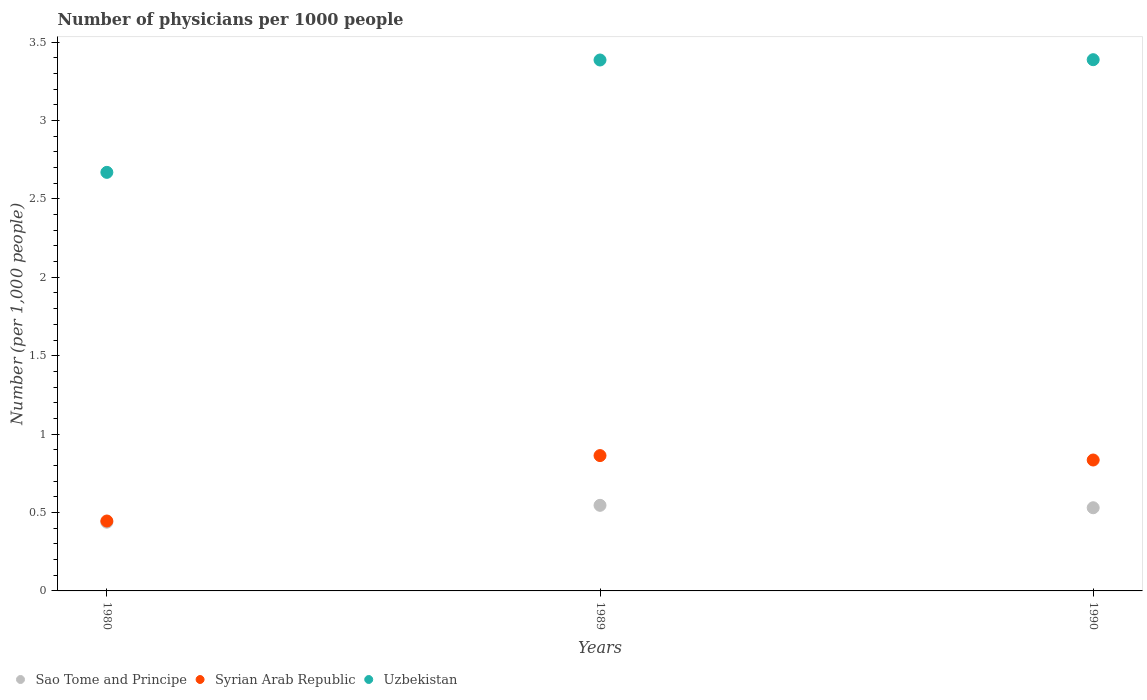Is the number of dotlines equal to the number of legend labels?
Your response must be concise. Yes. What is the number of physicians in Sao Tome and Principe in 1980?
Ensure brevity in your answer.  0.44. Across all years, what is the maximum number of physicians in Syrian Arab Republic?
Your answer should be compact. 0.86. Across all years, what is the minimum number of physicians in Syrian Arab Republic?
Ensure brevity in your answer.  0.45. In which year was the number of physicians in Sao Tome and Principe maximum?
Offer a terse response. 1989. In which year was the number of physicians in Uzbekistan minimum?
Keep it short and to the point. 1980. What is the total number of physicians in Sao Tome and Principe in the graph?
Your answer should be very brief. 1.51. What is the difference between the number of physicians in Uzbekistan in 1989 and that in 1990?
Provide a short and direct response. -0. What is the difference between the number of physicians in Syrian Arab Republic in 1980 and the number of physicians in Sao Tome and Principe in 1990?
Give a very brief answer. -0.08. What is the average number of physicians in Sao Tome and Principe per year?
Ensure brevity in your answer.  0.5. In the year 1989, what is the difference between the number of physicians in Sao Tome and Principe and number of physicians in Uzbekistan?
Keep it short and to the point. -2.84. In how many years, is the number of physicians in Syrian Arab Republic greater than 3.4?
Make the answer very short. 0. What is the ratio of the number of physicians in Syrian Arab Republic in 1980 to that in 1989?
Keep it short and to the point. 0.52. Is the number of physicians in Sao Tome and Principe in 1980 less than that in 1989?
Provide a succinct answer. Yes. Is the difference between the number of physicians in Sao Tome and Principe in 1989 and 1990 greater than the difference between the number of physicians in Uzbekistan in 1989 and 1990?
Your answer should be very brief. Yes. What is the difference between the highest and the second highest number of physicians in Uzbekistan?
Provide a succinct answer. 0. What is the difference between the highest and the lowest number of physicians in Sao Tome and Principe?
Keep it short and to the point. 0.11. Is it the case that in every year, the sum of the number of physicians in Uzbekistan and number of physicians in Syrian Arab Republic  is greater than the number of physicians in Sao Tome and Principe?
Keep it short and to the point. Yes. Is the number of physicians in Uzbekistan strictly less than the number of physicians in Sao Tome and Principe over the years?
Provide a succinct answer. No. How many dotlines are there?
Provide a succinct answer. 3. How many years are there in the graph?
Offer a very short reply. 3. How are the legend labels stacked?
Provide a short and direct response. Horizontal. What is the title of the graph?
Your response must be concise. Number of physicians per 1000 people. Does "Maldives" appear as one of the legend labels in the graph?
Provide a short and direct response. No. What is the label or title of the Y-axis?
Provide a short and direct response. Number (per 1,0 people). What is the Number (per 1,000 people) in Sao Tome and Principe in 1980?
Provide a short and direct response. 0.44. What is the Number (per 1,000 people) in Syrian Arab Republic in 1980?
Keep it short and to the point. 0.45. What is the Number (per 1,000 people) of Uzbekistan in 1980?
Your answer should be compact. 2.67. What is the Number (per 1,000 people) in Sao Tome and Principe in 1989?
Your response must be concise. 0.55. What is the Number (per 1,000 people) of Syrian Arab Republic in 1989?
Your answer should be very brief. 0.86. What is the Number (per 1,000 people) of Uzbekistan in 1989?
Give a very brief answer. 3.39. What is the Number (per 1,000 people) of Sao Tome and Principe in 1990?
Your response must be concise. 0.53. What is the Number (per 1,000 people) in Syrian Arab Republic in 1990?
Offer a terse response. 0.83. What is the Number (per 1,000 people) in Uzbekistan in 1990?
Keep it short and to the point. 3.39. Across all years, what is the maximum Number (per 1,000 people) of Sao Tome and Principe?
Give a very brief answer. 0.55. Across all years, what is the maximum Number (per 1,000 people) of Syrian Arab Republic?
Your answer should be very brief. 0.86. Across all years, what is the maximum Number (per 1,000 people) of Uzbekistan?
Offer a very short reply. 3.39. Across all years, what is the minimum Number (per 1,000 people) in Sao Tome and Principe?
Provide a succinct answer. 0.44. Across all years, what is the minimum Number (per 1,000 people) in Syrian Arab Republic?
Your answer should be very brief. 0.45. Across all years, what is the minimum Number (per 1,000 people) in Uzbekistan?
Your response must be concise. 2.67. What is the total Number (per 1,000 people) in Sao Tome and Principe in the graph?
Offer a very short reply. 1.51. What is the total Number (per 1,000 people) in Syrian Arab Republic in the graph?
Make the answer very short. 2.14. What is the total Number (per 1,000 people) of Uzbekistan in the graph?
Make the answer very short. 9.44. What is the difference between the Number (per 1,000 people) of Sao Tome and Principe in 1980 and that in 1989?
Your answer should be very brief. -0.11. What is the difference between the Number (per 1,000 people) of Syrian Arab Republic in 1980 and that in 1989?
Offer a terse response. -0.42. What is the difference between the Number (per 1,000 people) of Uzbekistan in 1980 and that in 1989?
Your response must be concise. -0.72. What is the difference between the Number (per 1,000 people) of Sao Tome and Principe in 1980 and that in 1990?
Provide a succinct answer. -0.09. What is the difference between the Number (per 1,000 people) of Syrian Arab Republic in 1980 and that in 1990?
Give a very brief answer. -0.39. What is the difference between the Number (per 1,000 people) in Uzbekistan in 1980 and that in 1990?
Provide a succinct answer. -0.72. What is the difference between the Number (per 1,000 people) in Sao Tome and Principe in 1989 and that in 1990?
Your answer should be compact. 0.02. What is the difference between the Number (per 1,000 people) of Syrian Arab Republic in 1989 and that in 1990?
Make the answer very short. 0.03. What is the difference between the Number (per 1,000 people) of Uzbekistan in 1989 and that in 1990?
Offer a very short reply. -0. What is the difference between the Number (per 1,000 people) in Sao Tome and Principe in 1980 and the Number (per 1,000 people) in Syrian Arab Republic in 1989?
Ensure brevity in your answer.  -0.42. What is the difference between the Number (per 1,000 people) of Sao Tome and Principe in 1980 and the Number (per 1,000 people) of Uzbekistan in 1989?
Make the answer very short. -2.95. What is the difference between the Number (per 1,000 people) in Syrian Arab Republic in 1980 and the Number (per 1,000 people) in Uzbekistan in 1989?
Offer a very short reply. -2.94. What is the difference between the Number (per 1,000 people) in Sao Tome and Principe in 1980 and the Number (per 1,000 people) in Syrian Arab Republic in 1990?
Make the answer very short. -0.4. What is the difference between the Number (per 1,000 people) in Sao Tome and Principe in 1980 and the Number (per 1,000 people) in Uzbekistan in 1990?
Offer a terse response. -2.95. What is the difference between the Number (per 1,000 people) in Syrian Arab Republic in 1980 and the Number (per 1,000 people) in Uzbekistan in 1990?
Offer a terse response. -2.94. What is the difference between the Number (per 1,000 people) in Sao Tome and Principe in 1989 and the Number (per 1,000 people) in Syrian Arab Republic in 1990?
Make the answer very short. -0.29. What is the difference between the Number (per 1,000 people) in Sao Tome and Principe in 1989 and the Number (per 1,000 people) in Uzbekistan in 1990?
Offer a very short reply. -2.84. What is the difference between the Number (per 1,000 people) in Syrian Arab Republic in 1989 and the Number (per 1,000 people) in Uzbekistan in 1990?
Ensure brevity in your answer.  -2.52. What is the average Number (per 1,000 people) of Sao Tome and Principe per year?
Your answer should be compact. 0.5. What is the average Number (per 1,000 people) of Syrian Arab Republic per year?
Ensure brevity in your answer.  0.71. What is the average Number (per 1,000 people) in Uzbekistan per year?
Offer a terse response. 3.15. In the year 1980, what is the difference between the Number (per 1,000 people) in Sao Tome and Principe and Number (per 1,000 people) in Syrian Arab Republic?
Offer a terse response. -0.01. In the year 1980, what is the difference between the Number (per 1,000 people) in Sao Tome and Principe and Number (per 1,000 people) in Uzbekistan?
Keep it short and to the point. -2.23. In the year 1980, what is the difference between the Number (per 1,000 people) of Syrian Arab Republic and Number (per 1,000 people) of Uzbekistan?
Make the answer very short. -2.22. In the year 1989, what is the difference between the Number (per 1,000 people) in Sao Tome and Principe and Number (per 1,000 people) in Syrian Arab Republic?
Provide a short and direct response. -0.32. In the year 1989, what is the difference between the Number (per 1,000 people) of Sao Tome and Principe and Number (per 1,000 people) of Uzbekistan?
Keep it short and to the point. -2.84. In the year 1989, what is the difference between the Number (per 1,000 people) of Syrian Arab Republic and Number (per 1,000 people) of Uzbekistan?
Your response must be concise. -2.52. In the year 1990, what is the difference between the Number (per 1,000 people) in Sao Tome and Principe and Number (per 1,000 people) in Syrian Arab Republic?
Make the answer very short. -0.3. In the year 1990, what is the difference between the Number (per 1,000 people) of Sao Tome and Principe and Number (per 1,000 people) of Uzbekistan?
Provide a succinct answer. -2.86. In the year 1990, what is the difference between the Number (per 1,000 people) of Syrian Arab Republic and Number (per 1,000 people) of Uzbekistan?
Ensure brevity in your answer.  -2.55. What is the ratio of the Number (per 1,000 people) in Sao Tome and Principe in 1980 to that in 1989?
Your answer should be compact. 0.8. What is the ratio of the Number (per 1,000 people) of Syrian Arab Republic in 1980 to that in 1989?
Give a very brief answer. 0.52. What is the ratio of the Number (per 1,000 people) of Uzbekistan in 1980 to that in 1989?
Provide a succinct answer. 0.79. What is the ratio of the Number (per 1,000 people) of Sao Tome and Principe in 1980 to that in 1990?
Offer a very short reply. 0.83. What is the ratio of the Number (per 1,000 people) in Syrian Arab Republic in 1980 to that in 1990?
Ensure brevity in your answer.  0.53. What is the ratio of the Number (per 1,000 people) of Uzbekistan in 1980 to that in 1990?
Provide a short and direct response. 0.79. What is the ratio of the Number (per 1,000 people) in Syrian Arab Republic in 1989 to that in 1990?
Give a very brief answer. 1.03. What is the ratio of the Number (per 1,000 people) of Uzbekistan in 1989 to that in 1990?
Your answer should be very brief. 1. What is the difference between the highest and the second highest Number (per 1,000 people) of Sao Tome and Principe?
Your response must be concise. 0.02. What is the difference between the highest and the second highest Number (per 1,000 people) of Syrian Arab Republic?
Ensure brevity in your answer.  0.03. What is the difference between the highest and the second highest Number (per 1,000 people) of Uzbekistan?
Ensure brevity in your answer.  0. What is the difference between the highest and the lowest Number (per 1,000 people) of Sao Tome and Principe?
Your answer should be very brief. 0.11. What is the difference between the highest and the lowest Number (per 1,000 people) in Syrian Arab Republic?
Your answer should be very brief. 0.42. What is the difference between the highest and the lowest Number (per 1,000 people) of Uzbekistan?
Your answer should be compact. 0.72. 